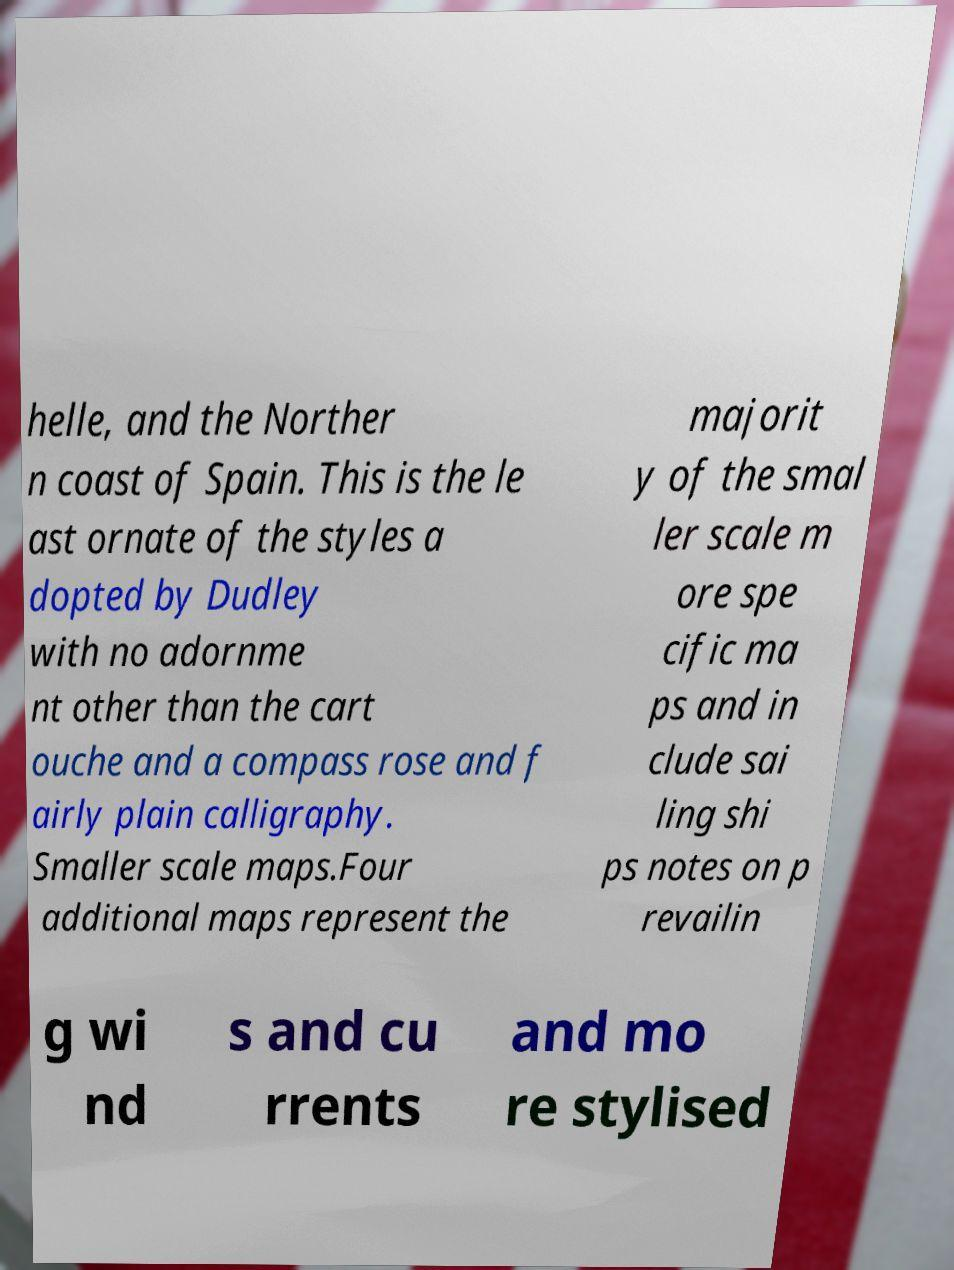Please read and relay the text visible in this image. What does it say? helle, and the Norther n coast of Spain. This is the le ast ornate of the styles a dopted by Dudley with no adornme nt other than the cart ouche and a compass rose and f airly plain calligraphy. Smaller scale maps.Four additional maps represent the majorit y of the smal ler scale m ore spe cific ma ps and in clude sai ling shi ps notes on p revailin g wi nd s and cu rrents and mo re stylised 